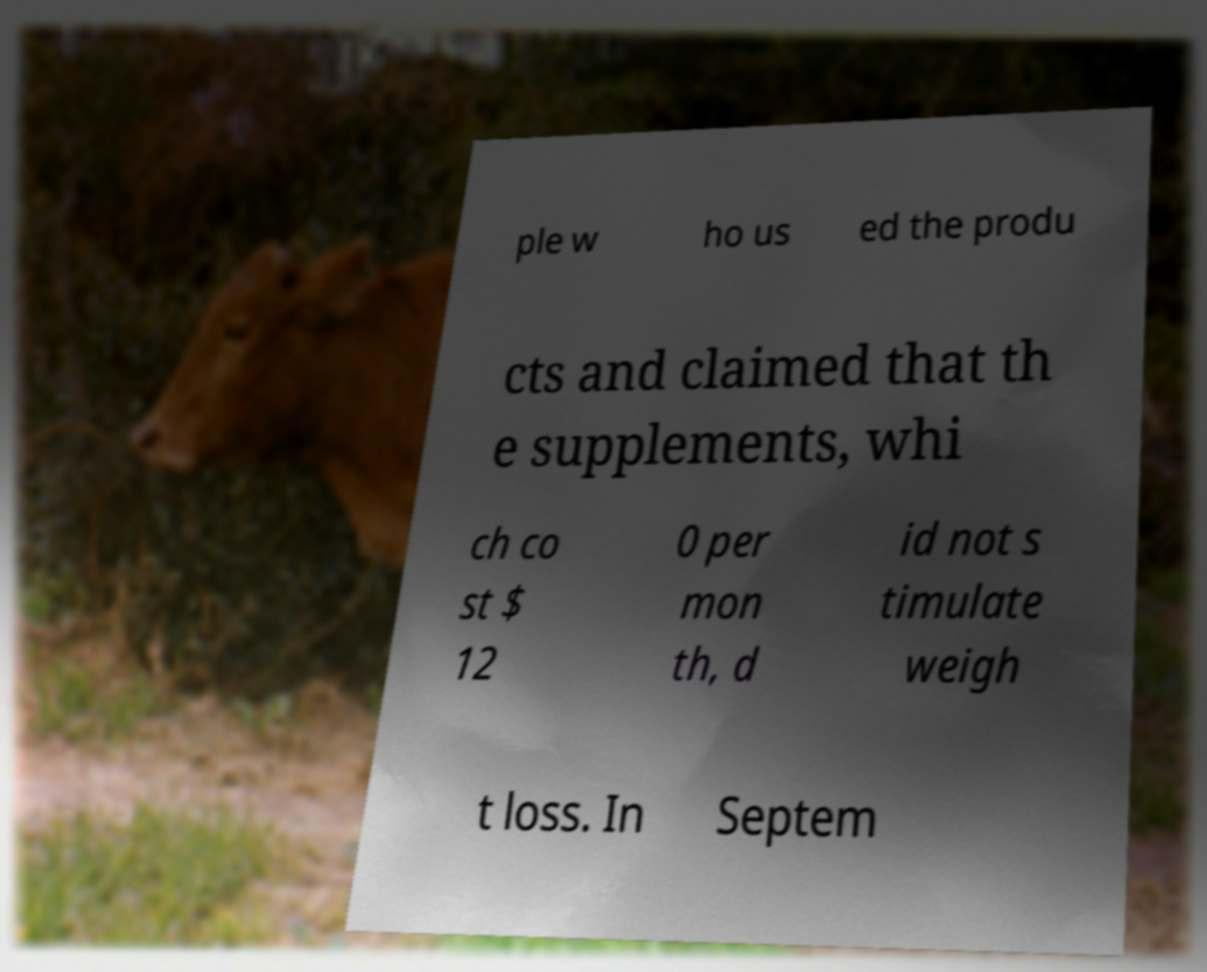What messages or text are displayed in this image? I need them in a readable, typed format. ple w ho us ed the produ cts and claimed that th e supplements, whi ch co st $ 12 0 per mon th, d id not s timulate weigh t loss. In Septem 